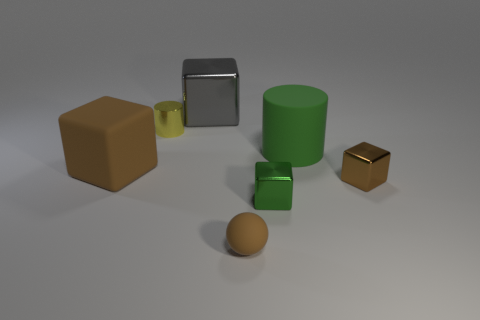Subtract all cyan spheres. How many brown blocks are left? 2 Subtract all green cubes. How many cubes are left? 3 Subtract all big rubber blocks. How many blocks are left? 3 Add 1 large brown things. How many objects exist? 8 Subtract all cyan blocks. Subtract all green spheres. How many blocks are left? 4 Add 2 tiny brown cubes. How many tiny brown cubes are left? 3 Add 1 large purple blocks. How many large purple blocks exist? 1 Subtract 0 purple cubes. How many objects are left? 7 Subtract all blocks. How many objects are left? 3 Subtract all gray things. Subtract all big brown things. How many objects are left? 5 